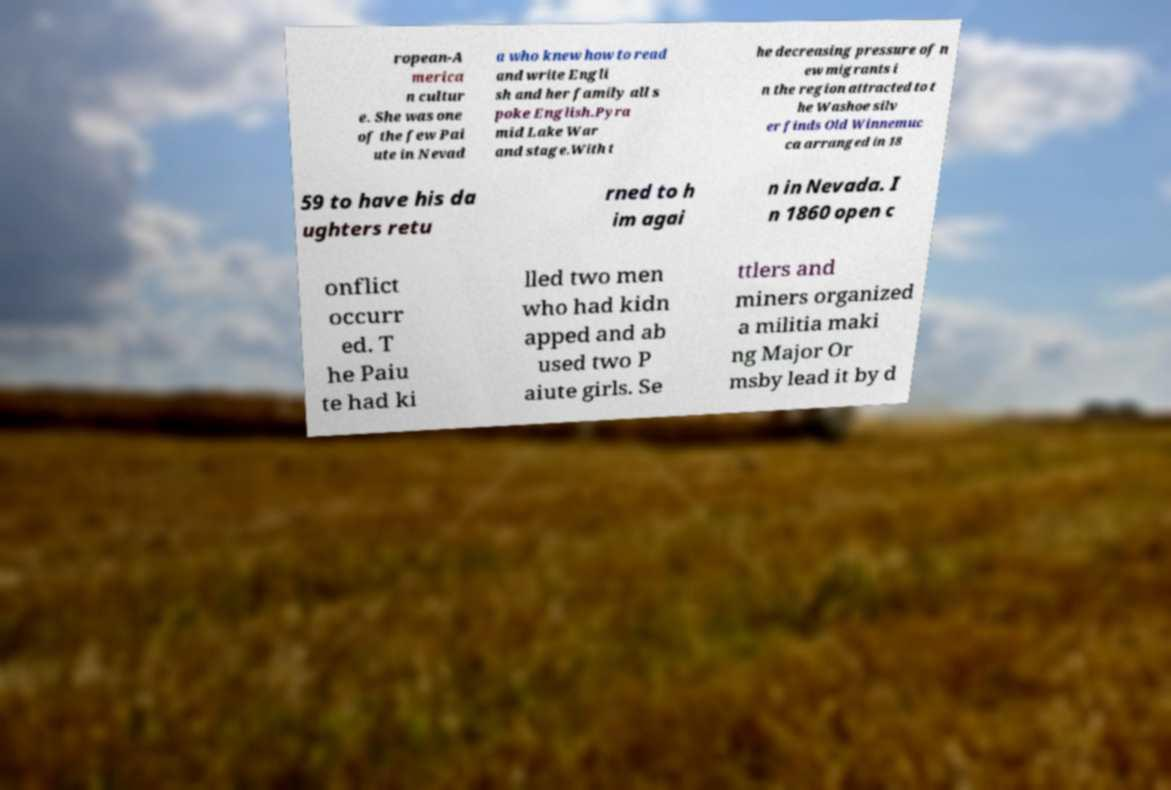For documentation purposes, I need the text within this image transcribed. Could you provide that? ropean-A merica n cultur e. She was one of the few Pai ute in Nevad a who knew how to read and write Engli sh and her family all s poke English.Pyra mid Lake War and stage.With t he decreasing pressure of n ew migrants i n the region attracted to t he Washoe silv er finds Old Winnemuc ca arranged in 18 59 to have his da ughters retu rned to h im agai n in Nevada. I n 1860 open c onflict occurr ed. T he Paiu te had ki lled two men who had kidn apped and ab used two P aiute girls. Se ttlers and miners organized a militia maki ng Major Or msby lead it by d 